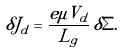Convert formula to latex. <formula><loc_0><loc_0><loc_500><loc_500>\delta J _ { d } = \frac { e \mu V _ { d } } { L _ { g } } \, \delta \Sigma .</formula> 